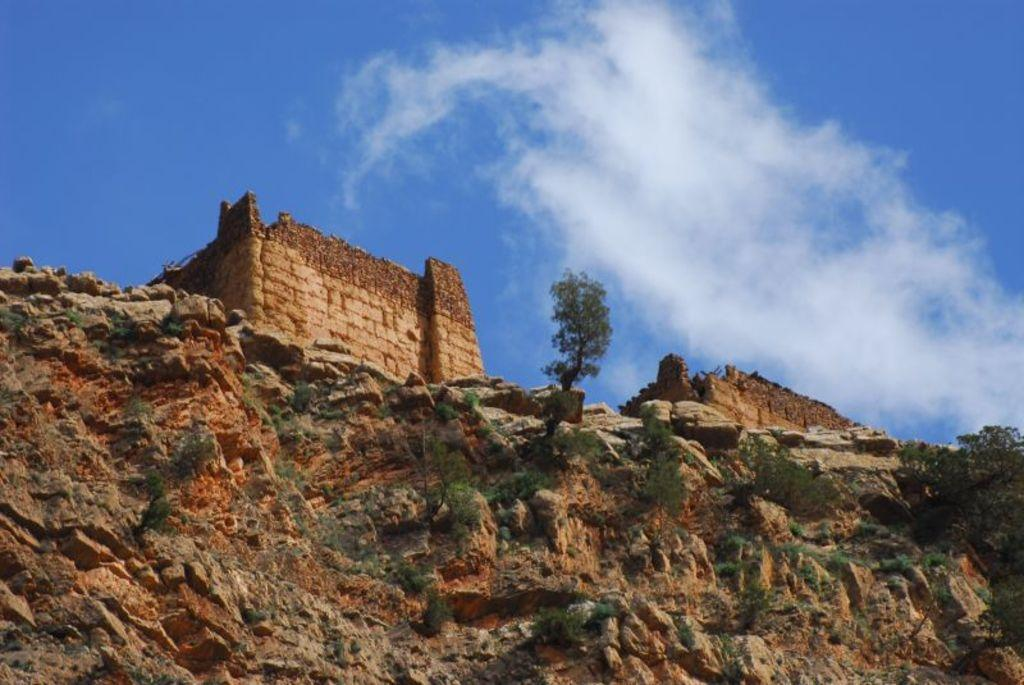What type of geological formation can be seen in the image? There is a rock hill in the image. What historical structures are present in the image? Ancient monuments are present in the image. What type of vegetation is visible in the image? There are trees in the image, and grass is also visible. What part of the natural environment is visible in the image? The sky is visible in the image, and clouds are present in the sky. How can you measure the depth of the cave in the image? There is no cave present in the image; it features a rock hill and ancient monuments. 